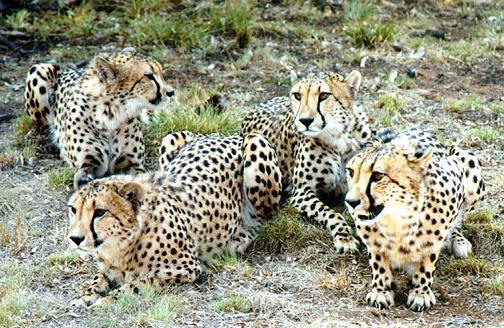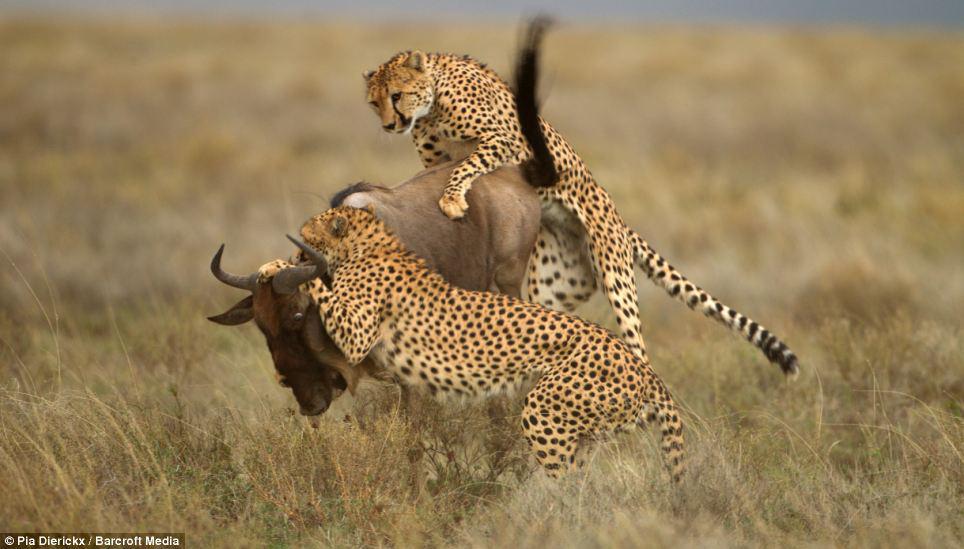The first image is the image on the left, the second image is the image on the right. Given the left and right images, does the statement "Multiple spotted wild cats are in action poses in one of the images." hold true? Answer yes or no. Yes. 